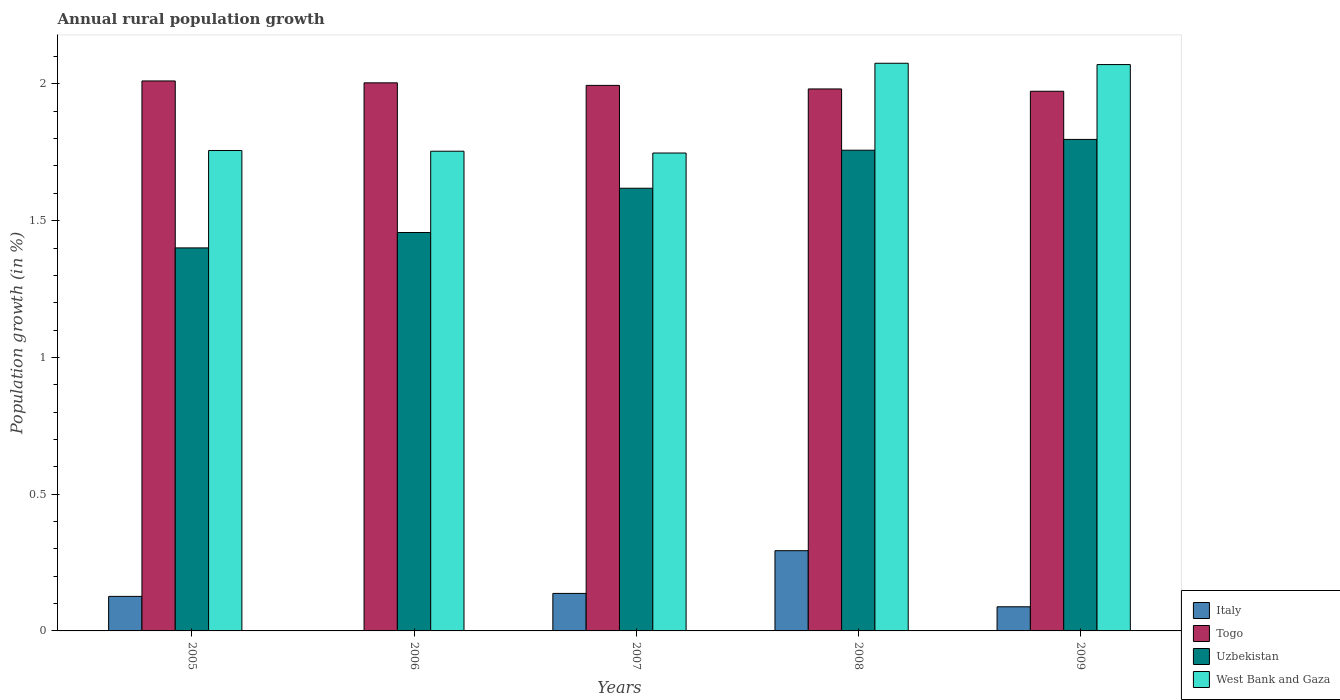How many different coloured bars are there?
Provide a short and direct response. 4. Are the number of bars on each tick of the X-axis equal?
Your response must be concise. No. How many bars are there on the 2nd tick from the left?
Provide a short and direct response. 3. How many bars are there on the 2nd tick from the right?
Offer a terse response. 4. What is the percentage of rural population growth in West Bank and Gaza in 2006?
Provide a short and direct response. 1.75. Across all years, what is the maximum percentage of rural population growth in Italy?
Offer a very short reply. 0.29. Across all years, what is the minimum percentage of rural population growth in Togo?
Ensure brevity in your answer.  1.97. In which year was the percentage of rural population growth in West Bank and Gaza maximum?
Your response must be concise. 2008. What is the total percentage of rural population growth in West Bank and Gaza in the graph?
Make the answer very short. 9.4. What is the difference between the percentage of rural population growth in West Bank and Gaza in 2007 and that in 2009?
Offer a very short reply. -0.32. What is the difference between the percentage of rural population growth in Togo in 2007 and the percentage of rural population growth in Italy in 2008?
Offer a terse response. 1.7. What is the average percentage of rural population growth in West Bank and Gaza per year?
Give a very brief answer. 1.88. In the year 2008, what is the difference between the percentage of rural population growth in Uzbekistan and percentage of rural population growth in West Bank and Gaza?
Give a very brief answer. -0.32. In how many years, is the percentage of rural population growth in West Bank and Gaza greater than 0.9 %?
Give a very brief answer. 5. What is the ratio of the percentage of rural population growth in Italy in 2005 to that in 2007?
Offer a very short reply. 0.92. Is the difference between the percentage of rural population growth in Uzbekistan in 2006 and 2008 greater than the difference between the percentage of rural population growth in West Bank and Gaza in 2006 and 2008?
Your response must be concise. Yes. What is the difference between the highest and the second highest percentage of rural population growth in Uzbekistan?
Offer a very short reply. 0.04. What is the difference between the highest and the lowest percentage of rural population growth in Togo?
Your answer should be compact. 0.04. In how many years, is the percentage of rural population growth in Uzbekistan greater than the average percentage of rural population growth in Uzbekistan taken over all years?
Your answer should be very brief. 3. Is the sum of the percentage of rural population growth in Italy in 2005 and 2009 greater than the maximum percentage of rural population growth in Uzbekistan across all years?
Your response must be concise. No. Are all the bars in the graph horizontal?
Offer a terse response. No. Are the values on the major ticks of Y-axis written in scientific E-notation?
Your answer should be very brief. No. Does the graph contain grids?
Keep it short and to the point. No. Where does the legend appear in the graph?
Provide a short and direct response. Bottom right. How are the legend labels stacked?
Give a very brief answer. Vertical. What is the title of the graph?
Keep it short and to the point. Annual rural population growth. What is the label or title of the X-axis?
Your response must be concise. Years. What is the label or title of the Y-axis?
Your response must be concise. Population growth (in %). What is the Population growth (in %) of Italy in 2005?
Keep it short and to the point. 0.13. What is the Population growth (in %) of Togo in 2005?
Keep it short and to the point. 2.01. What is the Population growth (in %) in Uzbekistan in 2005?
Your answer should be very brief. 1.4. What is the Population growth (in %) of West Bank and Gaza in 2005?
Your answer should be very brief. 1.76. What is the Population growth (in %) of Italy in 2006?
Provide a succinct answer. 0. What is the Population growth (in %) of Togo in 2006?
Provide a short and direct response. 2. What is the Population growth (in %) of Uzbekistan in 2006?
Make the answer very short. 1.46. What is the Population growth (in %) of West Bank and Gaza in 2006?
Keep it short and to the point. 1.75. What is the Population growth (in %) in Italy in 2007?
Offer a very short reply. 0.14. What is the Population growth (in %) of Togo in 2007?
Keep it short and to the point. 1.99. What is the Population growth (in %) of Uzbekistan in 2007?
Ensure brevity in your answer.  1.62. What is the Population growth (in %) in West Bank and Gaza in 2007?
Your answer should be compact. 1.75. What is the Population growth (in %) of Italy in 2008?
Your response must be concise. 0.29. What is the Population growth (in %) in Togo in 2008?
Offer a very short reply. 1.98. What is the Population growth (in %) in Uzbekistan in 2008?
Provide a succinct answer. 1.76. What is the Population growth (in %) of West Bank and Gaza in 2008?
Ensure brevity in your answer.  2.08. What is the Population growth (in %) in Italy in 2009?
Offer a terse response. 0.09. What is the Population growth (in %) of Togo in 2009?
Keep it short and to the point. 1.97. What is the Population growth (in %) in Uzbekistan in 2009?
Keep it short and to the point. 1.8. What is the Population growth (in %) in West Bank and Gaza in 2009?
Your answer should be compact. 2.07. Across all years, what is the maximum Population growth (in %) in Italy?
Give a very brief answer. 0.29. Across all years, what is the maximum Population growth (in %) in Togo?
Provide a succinct answer. 2.01. Across all years, what is the maximum Population growth (in %) in Uzbekistan?
Your answer should be very brief. 1.8. Across all years, what is the maximum Population growth (in %) in West Bank and Gaza?
Provide a short and direct response. 2.08. Across all years, what is the minimum Population growth (in %) of Togo?
Your response must be concise. 1.97. Across all years, what is the minimum Population growth (in %) in Uzbekistan?
Your response must be concise. 1.4. Across all years, what is the minimum Population growth (in %) in West Bank and Gaza?
Offer a terse response. 1.75. What is the total Population growth (in %) of Italy in the graph?
Offer a terse response. 0.65. What is the total Population growth (in %) in Togo in the graph?
Ensure brevity in your answer.  9.96. What is the total Population growth (in %) in Uzbekistan in the graph?
Your answer should be very brief. 8.03. What is the total Population growth (in %) in West Bank and Gaza in the graph?
Offer a terse response. 9.4. What is the difference between the Population growth (in %) of Togo in 2005 and that in 2006?
Give a very brief answer. 0.01. What is the difference between the Population growth (in %) of Uzbekistan in 2005 and that in 2006?
Your answer should be very brief. -0.06. What is the difference between the Population growth (in %) of West Bank and Gaza in 2005 and that in 2006?
Provide a short and direct response. 0. What is the difference between the Population growth (in %) in Italy in 2005 and that in 2007?
Your answer should be very brief. -0.01. What is the difference between the Population growth (in %) in Togo in 2005 and that in 2007?
Keep it short and to the point. 0.02. What is the difference between the Population growth (in %) of Uzbekistan in 2005 and that in 2007?
Offer a terse response. -0.22. What is the difference between the Population growth (in %) in West Bank and Gaza in 2005 and that in 2007?
Keep it short and to the point. 0.01. What is the difference between the Population growth (in %) of Italy in 2005 and that in 2008?
Your answer should be compact. -0.17. What is the difference between the Population growth (in %) in Togo in 2005 and that in 2008?
Offer a very short reply. 0.03. What is the difference between the Population growth (in %) of Uzbekistan in 2005 and that in 2008?
Ensure brevity in your answer.  -0.36. What is the difference between the Population growth (in %) in West Bank and Gaza in 2005 and that in 2008?
Offer a terse response. -0.32. What is the difference between the Population growth (in %) of Italy in 2005 and that in 2009?
Offer a terse response. 0.04. What is the difference between the Population growth (in %) of Togo in 2005 and that in 2009?
Ensure brevity in your answer.  0.04. What is the difference between the Population growth (in %) in Uzbekistan in 2005 and that in 2009?
Offer a very short reply. -0.4. What is the difference between the Population growth (in %) in West Bank and Gaza in 2005 and that in 2009?
Your answer should be very brief. -0.31. What is the difference between the Population growth (in %) in Togo in 2006 and that in 2007?
Provide a succinct answer. 0.01. What is the difference between the Population growth (in %) in Uzbekistan in 2006 and that in 2007?
Offer a terse response. -0.16. What is the difference between the Population growth (in %) in West Bank and Gaza in 2006 and that in 2007?
Give a very brief answer. 0.01. What is the difference between the Population growth (in %) in Togo in 2006 and that in 2008?
Your answer should be very brief. 0.02. What is the difference between the Population growth (in %) in Uzbekistan in 2006 and that in 2008?
Your answer should be compact. -0.3. What is the difference between the Population growth (in %) in West Bank and Gaza in 2006 and that in 2008?
Provide a succinct answer. -0.32. What is the difference between the Population growth (in %) in Togo in 2006 and that in 2009?
Your response must be concise. 0.03. What is the difference between the Population growth (in %) in Uzbekistan in 2006 and that in 2009?
Keep it short and to the point. -0.34. What is the difference between the Population growth (in %) of West Bank and Gaza in 2006 and that in 2009?
Provide a succinct answer. -0.32. What is the difference between the Population growth (in %) of Italy in 2007 and that in 2008?
Offer a very short reply. -0.16. What is the difference between the Population growth (in %) in Togo in 2007 and that in 2008?
Make the answer very short. 0.01. What is the difference between the Population growth (in %) of Uzbekistan in 2007 and that in 2008?
Provide a short and direct response. -0.14. What is the difference between the Population growth (in %) in West Bank and Gaza in 2007 and that in 2008?
Provide a short and direct response. -0.33. What is the difference between the Population growth (in %) of Italy in 2007 and that in 2009?
Keep it short and to the point. 0.05. What is the difference between the Population growth (in %) of Togo in 2007 and that in 2009?
Ensure brevity in your answer.  0.02. What is the difference between the Population growth (in %) in Uzbekistan in 2007 and that in 2009?
Your response must be concise. -0.18. What is the difference between the Population growth (in %) in West Bank and Gaza in 2007 and that in 2009?
Your answer should be compact. -0.32. What is the difference between the Population growth (in %) of Italy in 2008 and that in 2009?
Give a very brief answer. 0.21. What is the difference between the Population growth (in %) of Togo in 2008 and that in 2009?
Offer a very short reply. 0.01. What is the difference between the Population growth (in %) of Uzbekistan in 2008 and that in 2009?
Your answer should be very brief. -0.04. What is the difference between the Population growth (in %) of West Bank and Gaza in 2008 and that in 2009?
Your answer should be compact. 0. What is the difference between the Population growth (in %) in Italy in 2005 and the Population growth (in %) in Togo in 2006?
Make the answer very short. -1.88. What is the difference between the Population growth (in %) in Italy in 2005 and the Population growth (in %) in Uzbekistan in 2006?
Ensure brevity in your answer.  -1.33. What is the difference between the Population growth (in %) of Italy in 2005 and the Population growth (in %) of West Bank and Gaza in 2006?
Give a very brief answer. -1.63. What is the difference between the Population growth (in %) of Togo in 2005 and the Population growth (in %) of Uzbekistan in 2006?
Offer a terse response. 0.55. What is the difference between the Population growth (in %) in Togo in 2005 and the Population growth (in %) in West Bank and Gaza in 2006?
Ensure brevity in your answer.  0.26. What is the difference between the Population growth (in %) in Uzbekistan in 2005 and the Population growth (in %) in West Bank and Gaza in 2006?
Provide a short and direct response. -0.35. What is the difference between the Population growth (in %) of Italy in 2005 and the Population growth (in %) of Togo in 2007?
Your answer should be compact. -1.87. What is the difference between the Population growth (in %) in Italy in 2005 and the Population growth (in %) in Uzbekistan in 2007?
Offer a very short reply. -1.49. What is the difference between the Population growth (in %) in Italy in 2005 and the Population growth (in %) in West Bank and Gaza in 2007?
Offer a very short reply. -1.62. What is the difference between the Population growth (in %) in Togo in 2005 and the Population growth (in %) in Uzbekistan in 2007?
Keep it short and to the point. 0.39. What is the difference between the Population growth (in %) of Togo in 2005 and the Population growth (in %) of West Bank and Gaza in 2007?
Ensure brevity in your answer.  0.26. What is the difference between the Population growth (in %) of Uzbekistan in 2005 and the Population growth (in %) of West Bank and Gaza in 2007?
Give a very brief answer. -0.35. What is the difference between the Population growth (in %) in Italy in 2005 and the Population growth (in %) in Togo in 2008?
Your answer should be very brief. -1.86. What is the difference between the Population growth (in %) of Italy in 2005 and the Population growth (in %) of Uzbekistan in 2008?
Provide a short and direct response. -1.63. What is the difference between the Population growth (in %) in Italy in 2005 and the Population growth (in %) in West Bank and Gaza in 2008?
Provide a succinct answer. -1.95. What is the difference between the Population growth (in %) in Togo in 2005 and the Population growth (in %) in Uzbekistan in 2008?
Ensure brevity in your answer.  0.25. What is the difference between the Population growth (in %) in Togo in 2005 and the Population growth (in %) in West Bank and Gaza in 2008?
Ensure brevity in your answer.  -0.06. What is the difference between the Population growth (in %) of Uzbekistan in 2005 and the Population growth (in %) of West Bank and Gaza in 2008?
Offer a very short reply. -0.68. What is the difference between the Population growth (in %) in Italy in 2005 and the Population growth (in %) in Togo in 2009?
Provide a succinct answer. -1.85. What is the difference between the Population growth (in %) of Italy in 2005 and the Population growth (in %) of Uzbekistan in 2009?
Your answer should be compact. -1.67. What is the difference between the Population growth (in %) in Italy in 2005 and the Population growth (in %) in West Bank and Gaza in 2009?
Ensure brevity in your answer.  -1.94. What is the difference between the Population growth (in %) in Togo in 2005 and the Population growth (in %) in Uzbekistan in 2009?
Offer a terse response. 0.21. What is the difference between the Population growth (in %) in Togo in 2005 and the Population growth (in %) in West Bank and Gaza in 2009?
Make the answer very short. -0.06. What is the difference between the Population growth (in %) of Uzbekistan in 2005 and the Population growth (in %) of West Bank and Gaza in 2009?
Keep it short and to the point. -0.67. What is the difference between the Population growth (in %) of Togo in 2006 and the Population growth (in %) of Uzbekistan in 2007?
Offer a terse response. 0.39. What is the difference between the Population growth (in %) of Togo in 2006 and the Population growth (in %) of West Bank and Gaza in 2007?
Provide a short and direct response. 0.26. What is the difference between the Population growth (in %) of Uzbekistan in 2006 and the Population growth (in %) of West Bank and Gaza in 2007?
Provide a succinct answer. -0.29. What is the difference between the Population growth (in %) in Togo in 2006 and the Population growth (in %) in Uzbekistan in 2008?
Provide a succinct answer. 0.25. What is the difference between the Population growth (in %) of Togo in 2006 and the Population growth (in %) of West Bank and Gaza in 2008?
Your answer should be very brief. -0.07. What is the difference between the Population growth (in %) of Uzbekistan in 2006 and the Population growth (in %) of West Bank and Gaza in 2008?
Your response must be concise. -0.62. What is the difference between the Population growth (in %) in Togo in 2006 and the Population growth (in %) in Uzbekistan in 2009?
Your response must be concise. 0.21. What is the difference between the Population growth (in %) in Togo in 2006 and the Population growth (in %) in West Bank and Gaza in 2009?
Your answer should be compact. -0.07. What is the difference between the Population growth (in %) of Uzbekistan in 2006 and the Population growth (in %) of West Bank and Gaza in 2009?
Your answer should be compact. -0.61. What is the difference between the Population growth (in %) of Italy in 2007 and the Population growth (in %) of Togo in 2008?
Provide a succinct answer. -1.84. What is the difference between the Population growth (in %) in Italy in 2007 and the Population growth (in %) in Uzbekistan in 2008?
Keep it short and to the point. -1.62. What is the difference between the Population growth (in %) in Italy in 2007 and the Population growth (in %) in West Bank and Gaza in 2008?
Provide a succinct answer. -1.94. What is the difference between the Population growth (in %) of Togo in 2007 and the Population growth (in %) of Uzbekistan in 2008?
Make the answer very short. 0.24. What is the difference between the Population growth (in %) in Togo in 2007 and the Population growth (in %) in West Bank and Gaza in 2008?
Provide a succinct answer. -0.08. What is the difference between the Population growth (in %) of Uzbekistan in 2007 and the Population growth (in %) of West Bank and Gaza in 2008?
Offer a terse response. -0.46. What is the difference between the Population growth (in %) in Italy in 2007 and the Population growth (in %) in Togo in 2009?
Keep it short and to the point. -1.84. What is the difference between the Population growth (in %) in Italy in 2007 and the Population growth (in %) in Uzbekistan in 2009?
Keep it short and to the point. -1.66. What is the difference between the Population growth (in %) of Italy in 2007 and the Population growth (in %) of West Bank and Gaza in 2009?
Offer a terse response. -1.93. What is the difference between the Population growth (in %) of Togo in 2007 and the Population growth (in %) of Uzbekistan in 2009?
Offer a very short reply. 0.2. What is the difference between the Population growth (in %) in Togo in 2007 and the Population growth (in %) in West Bank and Gaza in 2009?
Provide a succinct answer. -0.08. What is the difference between the Population growth (in %) in Uzbekistan in 2007 and the Population growth (in %) in West Bank and Gaza in 2009?
Provide a succinct answer. -0.45. What is the difference between the Population growth (in %) in Italy in 2008 and the Population growth (in %) in Togo in 2009?
Give a very brief answer. -1.68. What is the difference between the Population growth (in %) of Italy in 2008 and the Population growth (in %) of Uzbekistan in 2009?
Give a very brief answer. -1.5. What is the difference between the Population growth (in %) of Italy in 2008 and the Population growth (in %) of West Bank and Gaza in 2009?
Offer a very short reply. -1.78. What is the difference between the Population growth (in %) of Togo in 2008 and the Population growth (in %) of Uzbekistan in 2009?
Provide a succinct answer. 0.18. What is the difference between the Population growth (in %) of Togo in 2008 and the Population growth (in %) of West Bank and Gaza in 2009?
Provide a short and direct response. -0.09. What is the difference between the Population growth (in %) of Uzbekistan in 2008 and the Population growth (in %) of West Bank and Gaza in 2009?
Make the answer very short. -0.31. What is the average Population growth (in %) of Italy per year?
Provide a succinct answer. 0.13. What is the average Population growth (in %) of Togo per year?
Provide a succinct answer. 1.99. What is the average Population growth (in %) in Uzbekistan per year?
Offer a terse response. 1.61. What is the average Population growth (in %) in West Bank and Gaza per year?
Ensure brevity in your answer.  1.88. In the year 2005, what is the difference between the Population growth (in %) in Italy and Population growth (in %) in Togo?
Provide a succinct answer. -1.88. In the year 2005, what is the difference between the Population growth (in %) of Italy and Population growth (in %) of Uzbekistan?
Offer a terse response. -1.27. In the year 2005, what is the difference between the Population growth (in %) of Italy and Population growth (in %) of West Bank and Gaza?
Your answer should be compact. -1.63. In the year 2005, what is the difference between the Population growth (in %) of Togo and Population growth (in %) of Uzbekistan?
Offer a very short reply. 0.61. In the year 2005, what is the difference between the Population growth (in %) of Togo and Population growth (in %) of West Bank and Gaza?
Your response must be concise. 0.25. In the year 2005, what is the difference between the Population growth (in %) in Uzbekistan and Population growth (in %) in West Bank and Gaza?
Offer a very short reply. -0.36. In the year 2006, what is the difference between the Population growth (in %) in Togo and Population growth (in %) in Uzbekistan?
Your answer should be very brief. 0.55. In the year 2006, what is the difference between the Population growth (in %) in Uzbekistan and Population growth (in %) in West Bank and Gaza?
Your answer should be very brief. -0.3. In the year 2007, what is the difference between the Population growth (in %) in Italy and Population growth (in %) in Togo?
Your response must be concise. -1.86. In the year 2007, what is the difference between the Population growth (in %) in Italy and Population growth (in %) in Uzbekistan?
Ensure brevity in your answer.  -1.48. In the year 2007, what is the difference between the Population growth (in %) of Italy and Population growth (in %) of West Bank and Gaza?
Your response must be concise. -1.61. In the year 2007, what is the difference between the Population growth (in %) of Togo and Population growth (in %) of Uzbekistan?
Ensure brevity in your answer.  0.38. In the year 2007, what is the difference between the Population growth (in %) in Togo and Population growth (in %) in West Bank and Gaza?
Ensure brevity in your answer.  0.25. In the year 2007, what is the difference between the Population growth (in %) in Uzbekistan and Population growth (in %) in West Bank and Gaza?
Provide a short and direct response. -0.13. In the year 2008, what is the difference between the Population growth (in %) of Italy and Population growth (in %) of Togo?
Provide a short and direct response. -1.69. In the year 2008, what is the difference between the Population growth (in %) in Italy and Population growth (in %) in Uzbekistan?
Ensure brevity in your answer.  -1.46. In the year 2008, what is the difference between the Population growth (in %) of Italy and Population growth (in %) of West Bank and Gaza?
Your answer should be very brief. -1.78. In the year 2008, what is the difference between the Population growth (in %) in Togo and Population growth (in %) in Uzbekistan?
Offer a very short reply. 0.22. In the year 2008, what is the difference between the Population growth (in %) in Togo and Population growth (in %) in West Bank and Gaza?
Your response must be concise. -0.09. In the year 2008, what is the difference between the Population growth (in %) of Uzbekistan and Population growth (in %) of West Bank and Gaza?
Provide a short and direct response. -0.32. In the year 2009, what is the difference between the Population growth (in %) of Italy and Population growth (in %) of Togo?
Your answer should be compact. -1.89. In the year 2009, what is the difference between the Population growth (in %) in Italy and Population growth (in %) in Uzbekistan?
Your answer should be compact. -1.71. In the year 2009, what is the difference between the Population growth (in %) of Italy and Population growth (in %) of West Bank and Gaza?
Provide a short and direct response. -1.98. In the year 2009, what is the difference between the Population growth (in %) in Togo and Population growth (in %) in Uzbekistan?
Ensure brevity in your answer.  0.18. In the year 2009, what is the difference between the Population growth (in %) of Togo and Population growth (in %) of West Bank and Gaza?
Keep it short and to the point. -0.1. In the year 2009, what is the difference between the Population growth (in %) in Uzbekistan and Population growth (in %) in West Bank and Gaza?
Provide a succinct answer. -0.27. What is the ratio of the Population growth (in %) in Uzbekistan in 2005 to that in 2006?
Ensure brevity in your answer.  0.96. What is the ratio of the Population growth (in %) of West Bank and Gaza in 2005 to that in 2006?
Provide a succinct answer. 1. What is the ratio of the Population growth (in %) of Italy in 2005 to that in 2007?
Ensure brevity in your answer.  0.92. What is the ratio of the Population growth (in %) in Uzbekistan in 2005 to that in 2007?
Keep it short and to the point. 0.87. What is the ratio of the Population growth (in %) in West Bank and Gaza in 2005 to that in 2007?
Ensure brevity in your answer.  1.01. What is the ratio of the Population growth (in %) of Italy in 2005 to that in 2008?
Make the answer very short. 0.43. What is the ratio of the Population growth (in %) of Togo in 2005 to that in 2008?
Provide a succinct answer. 1.01. What is the ratio of the Population growth (in %) in Uzbekistan in 2005 to that in 2008?
Offer a very short reply. 0.8. What is the ratio of the Population growth (in %) in West Bank and Gaza in 2005 to that in 2008?
Keep it short and to the point. 0.85. What is the ratio of the Population growth (in %) of Italy in 2005 to that in 2009?
Provide a succinct answer. 1.43. What is the ratio of the Population growth (in %) of Togo in 2005 to that in 2009?
Offer a terse response. 1.02. What is the ratio of the Population growth (in %) of Uzbekistan in 2005 to that in 2009?
Provide a short and direct response. 0.78. What is the ratio of the Population growth (in %) of West Bank and Gaza in 2005 to that in 2009?
Give a very brief answer. 0.85. What is the ratio of the Population growth (in %) of Uzbekistan in 2006 to that in 2007?
Your answer should be very brief. 0.9. What is the ratio of the Population growth (in %) of Togo in 2006 to that in 2008?
Keep it short and to the point. 1.01. What is the ratio of the Population growth (in %) in Uzbekistan in 2006 to that in 2008?
Offer a very short reply. 0.83. What is the ratio of the Population growth (in %) in West Bank and Gaza in 2006 to that in 2008?
Your response must be concise. 0.85. What is the ratio of the Population growth (in %) in Togo in 2006 to that in 2009?
Your answer should be compact. 1.02. What is the ratio of the Population growth (in %) of Uzbekistan in 2006 to that in 2009?
Ensure brevity in your answer.  0.81. What is the ratio of the Population growth (in %) in West Bank and Gaza in 2006 to that in 2009?
Your answer should be compact. 0.85. What is the ratio of the Population growth (in %) of Italy in 2007 to that in 2008?
Ensure brevity in your answer.  0.47. What is the ratio of the Population growth (in %) of Togo in 2007 to that in 2008?
Your answer should be compact. 1.01. What is the ratio of the Population growth (in %) in Uzbekistan in 2007 to that in 2008?
Provide a short and direct response. 0.92. What is the ratio of the Population growth (in %) in West Bank and Gaza in 2007 to that in 2008?
Ensure brevity in your answer.  0.84. What is the ratio of the Population growth (in %) in Italy in 2007 to that in 2009?
Your answer should be very brief. 1.55. What is the ratio of the Population growth (in %) of Togo in 2007 to that in 2009?
Make the answer very short. 1.01. What is the ratio of the Population growth (in %) of Uzbekistan in 2007 to that in 2009?
Give a very brief answer. 0.9. What is the ratio of the Population growth (in %) in West Bank and Gaza in 2007 to that in 2009?
Make the answer very short. 0.84. What is the ratio of the Population growth (in %) of Italy in 2008 to that in 2009?
Offer a terse response. 3.32. What is the difference between the highest and the second highest Population growth (in %) of Italy?
Your answer should be very brief. 0.16. What is the difference between the highest and the second highest Population growth (in %) of Togo?
Your response must be concise. 0.01. What is the difference between the highest and the second highest Population growth (in %) in Uzbekistan?
Make the answer very short. 0.04. What is the difference between the highest and the second highest Population growth (in %) in West Bank and Gaza?
Your response must be concise. 0. What is the difference between the highest and the lowest Population growth (in %) of Italy?
Give a very brief answer. 0.29. What is the difference between the highest and the lowest Population growth (in %) of Togo?
Make the answer very short. 0.04. What is the difference between the highest and the lowest Population growth (in %) in Uzbekistan?
Ensure brevity in your answer.  0.4. What is the difference between the highest and the lowest Population growth (in %) of West Bank and Gaza?
Your response must be concise. 0.33. 